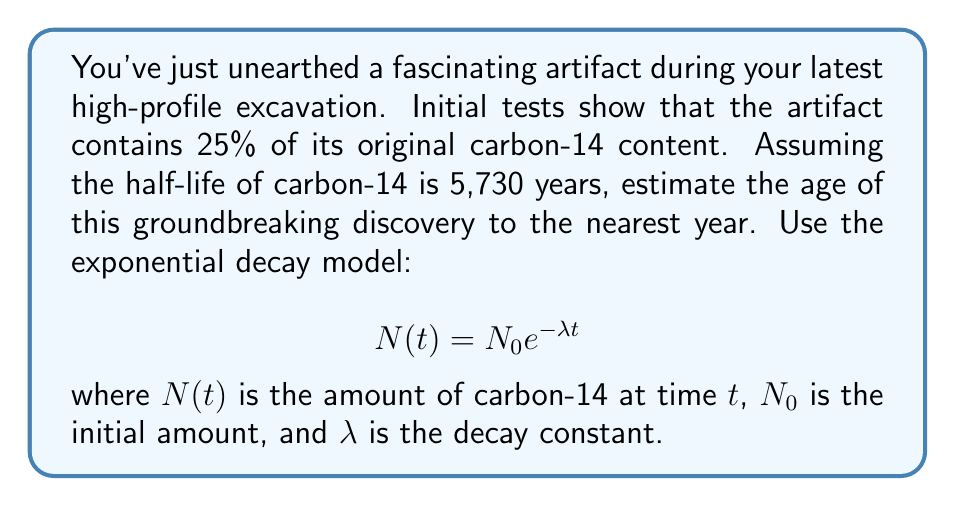Could you help me with this problem? 1. First, we need to calculate the decay constant $\lambda$:
   Half-life $T_{1/2} = 5,730$ years
   $$\lambda = \frac{\ln(2)}{T_{1/2}} = \frac{\ln(2)}{5,730} \approx 0.000121$$

2. We know that the current amount is 25% of the original, so:
   $$\frac{N(t)}{N_0} = 0.25$$

3. Substituting into the exponential decay model:
   $$0.25 = e^{-\lambda t}$$

4. Taking the natural logarithm of both sides:
   $$\ln(0.25) = -\lambda t$$

5. Solving for $t$:
   $$t = -\frac{\ln(0.25)}{\lambda} = -\frac{\ln(0.25)}{0.000121} \approx 11,460.15$$

6. Rounding to the nearest year:
   $t \approx 11,460$ years
Answer: 11,460 years 